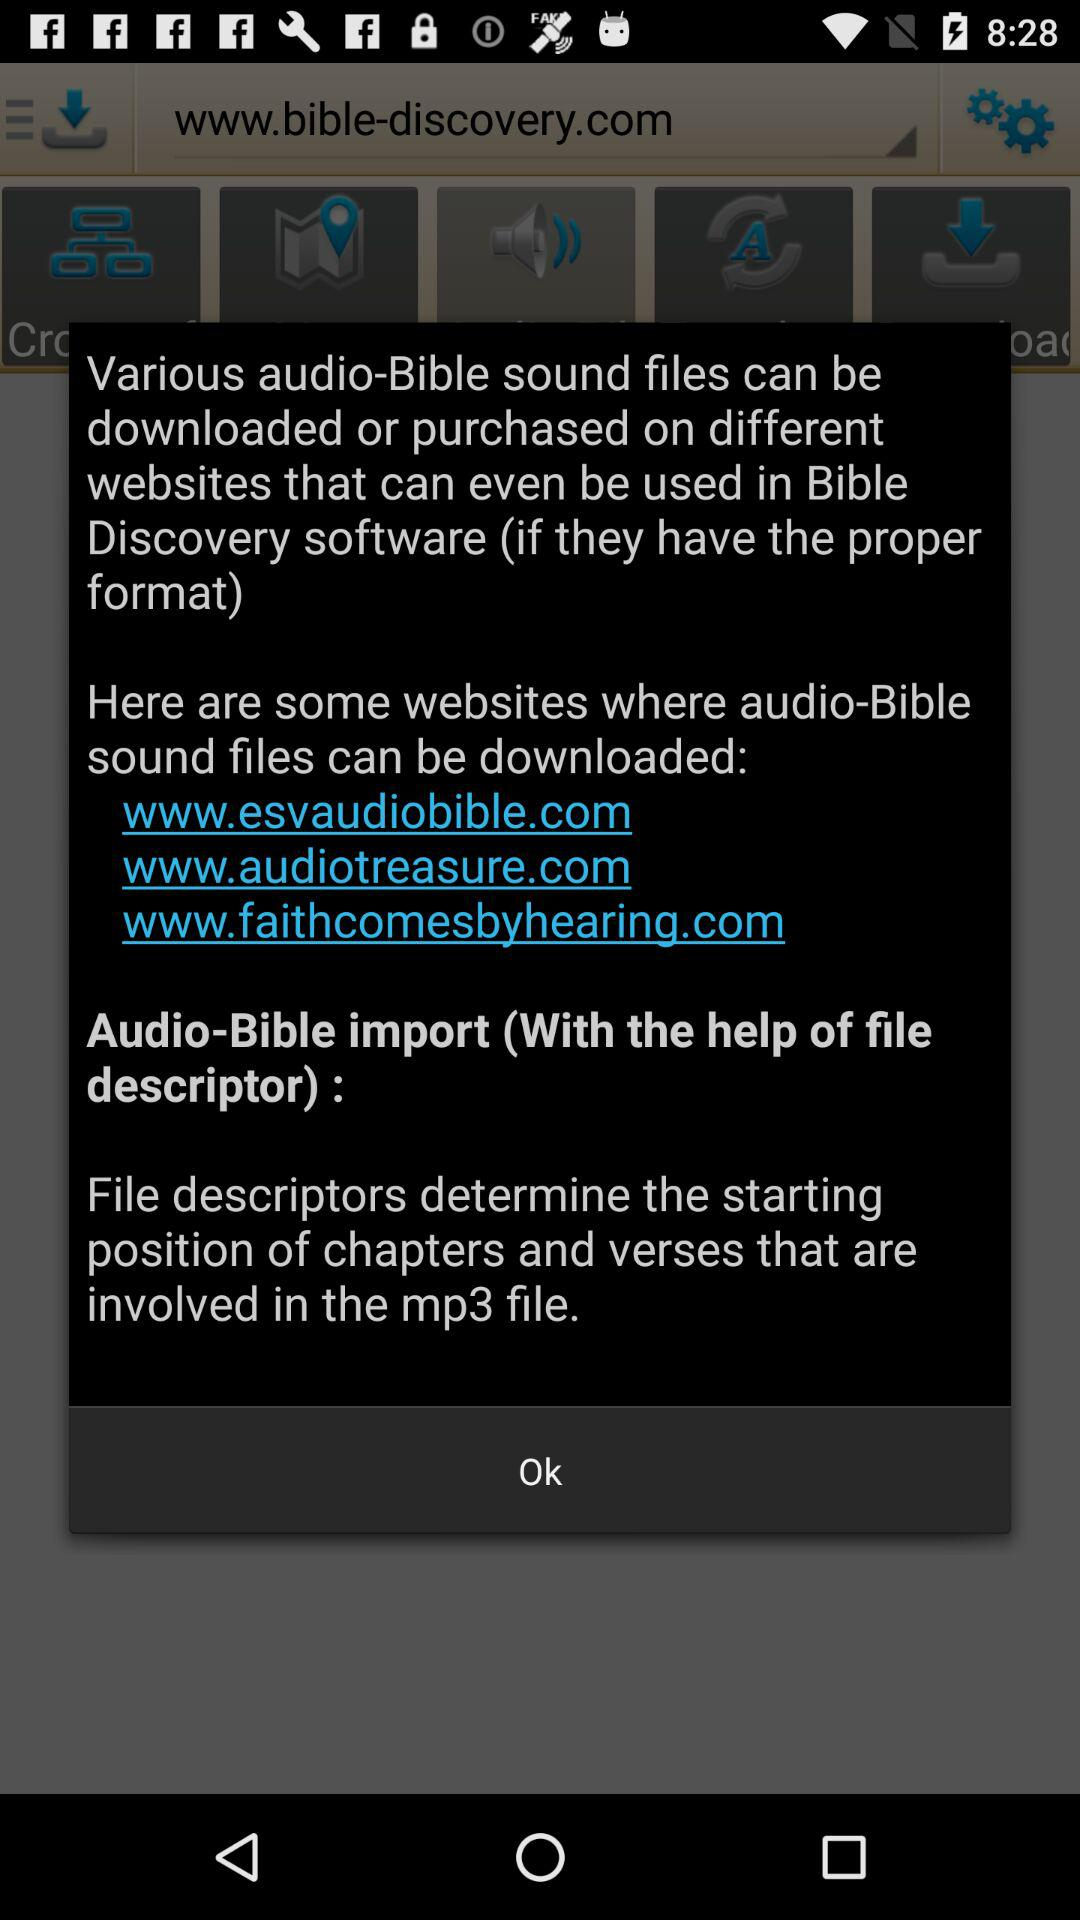How many websites are mentioned where audio-Bible sound files can be downloaded?
Answer the question using a single word or phrase. 3 